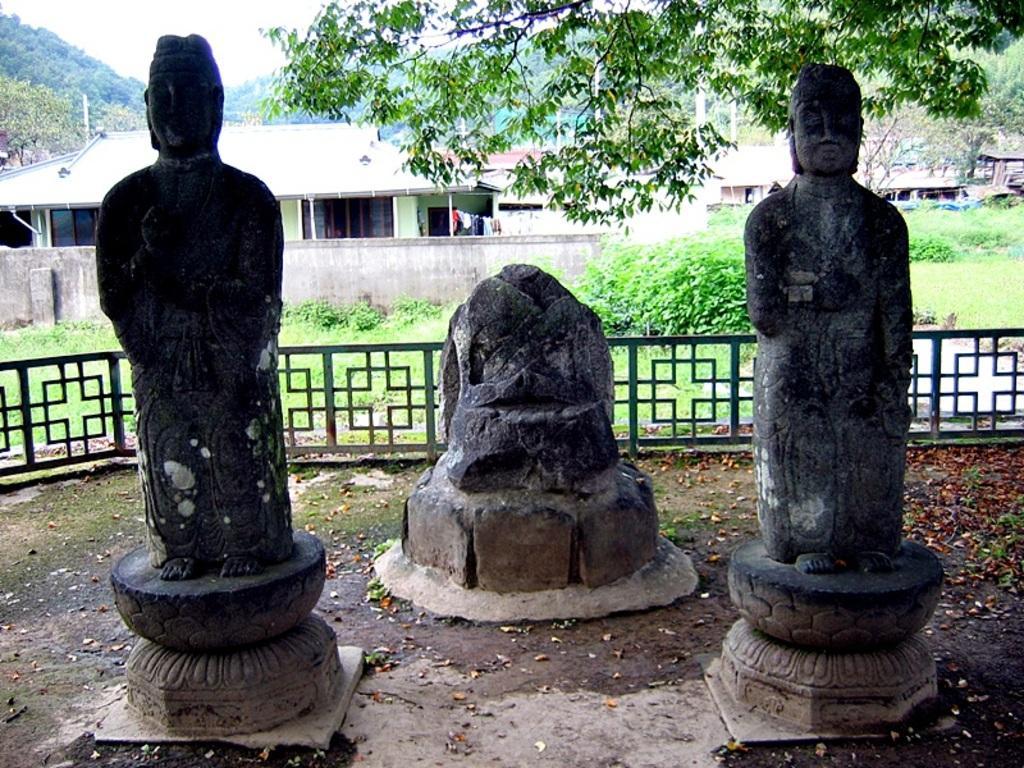Please provide a concise description of this image. In this image I can see there are three statues, at the back side there are houses and trees, at the top it is the sky. 